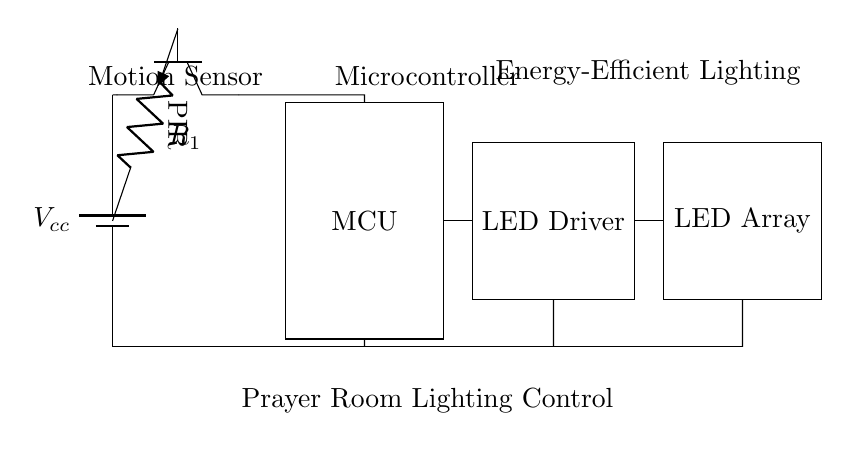What type of sensor is used in this circuit? The circuit utilizes a PIR (Passive Infrared) sensor, which is indicated by the label on the diagram. PIR sensors detect motion based on changes in infrared radiation, often emitted by human bodies.
Answer: PIR How many primary components are in this circuit? The circuit features four main components: the PIR sensor, microcontroller, LED driver, and LED array. These components work together to create an energy-efficient lighting solution.
Answer: Four What is the purpose of the microcontroller in this circuit? The microcontroller (MCU) processes the signals received from the PIR sensor and controls the LED driver accordingly. It is essential for managing the logic of the lighting system based on detected motion.
Answer: Control What component limits the current from the PIR sensor to the microcontroller? The resistor labeled R1 limits the current from the PIR sensor to the microcontroller, ensuring the Microcontroller receives a safe level of current for its operation and prevents damage.
Answer: R1 How does the motion sensor contribute to energy efficiency? The motion sensor activates the lighting only when motion is detected, which means the lights will remain off when the prayer room is unoccupied, reducing unnecessary energy consumption.
Answer: By detecting motion What is the output element that actually produces light in this circuit? The LED array is the component that produces light, working in conjunction with the LED driver to illuminate the prayer room when activated by the microcontroller.
Answer: LED array Which component provides power to the entire circuit? The circuit is powered by a battery, as indicated by the symbol and label showing Vcc; it provides the necessary voltage for all the components to function correctly.
Answer: Battery 